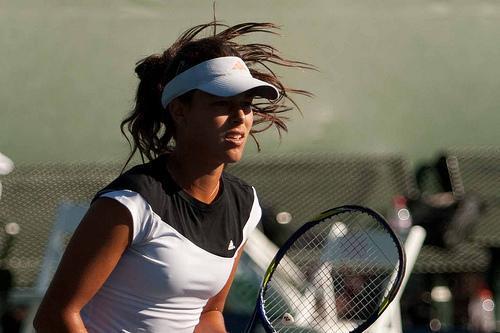How many people are visible?
Give a very brief answer. 1. How many nipples can be seen through the shirt?
Give a very brief answer. 1. 